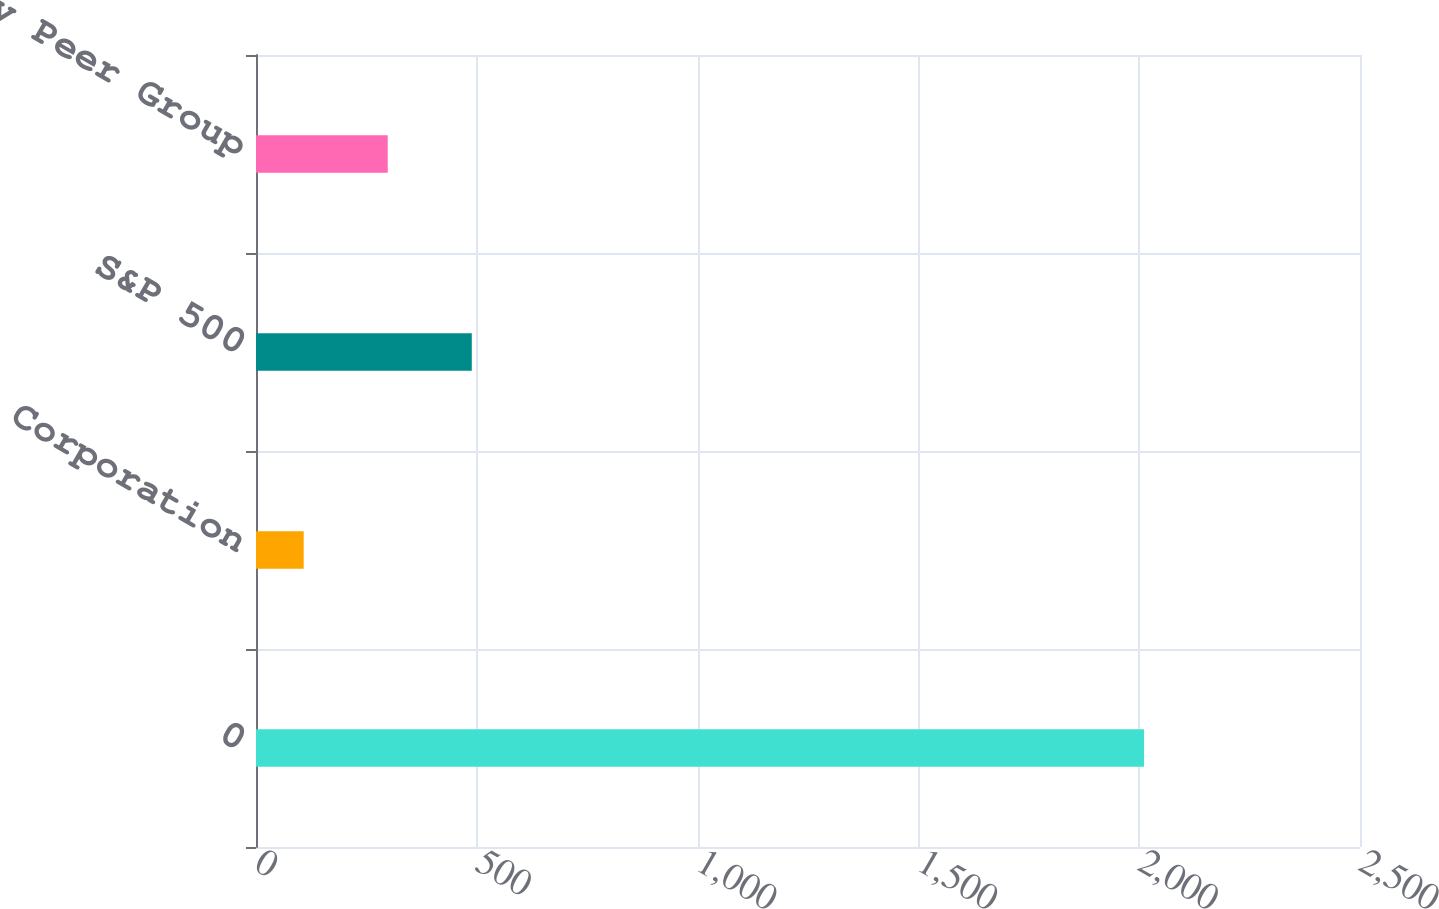Convert chart to OTSL. <chart><loc_0><loc_0><loc_500><loc_500><bar_chart><fcel>0<fcel>Hess Corporation<fcel>S&P 500<fcel>Proxy Peer Group<nl><fcel>2011<fcel>108.03<fcel>488.63<fcel>298.33<nl></chart> 